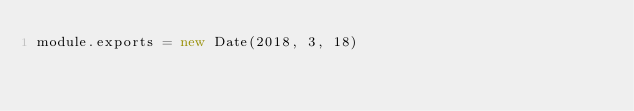Convert code to text. <code><loc_0><loc_0><loc_500><loc_500><_JavaScript_>module.exports = new Date(2018, 3, 18)
</code> 